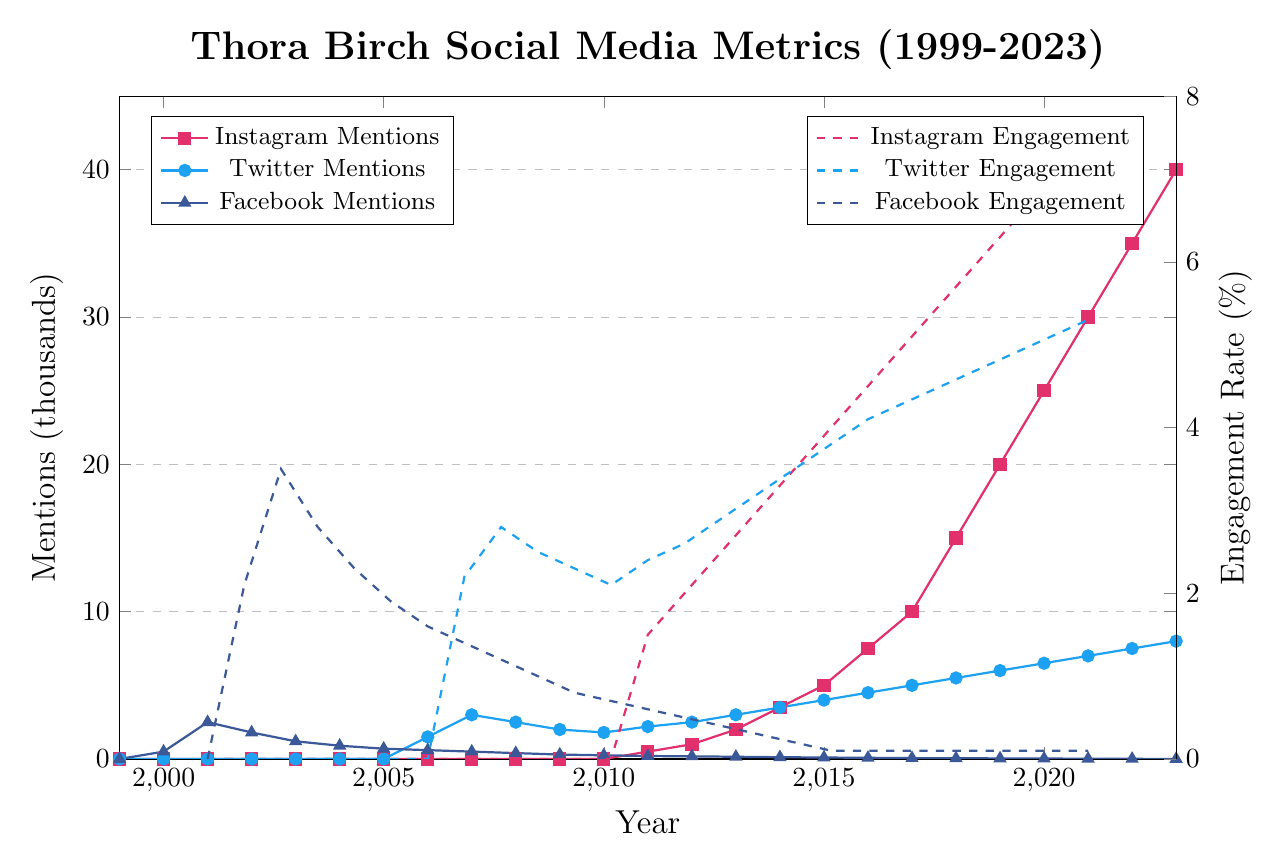What's the overall trend in Instagram mentions from 1999 to 2023? The figure shows a steady increase in Instagram mentions starting from 2011, reaching 40,000 in 2023. Initially, there were no mentions from 1999 to 2010.
Answer: Increasing How do the Twitter and Facebook mentions in 2007 compare? In 2007, Twitter mentions are represented by the blue line and marker, while Facebook mentions are represented by the blue line and triangle marker. Twitter mentions are at 3,000 and Facebook mentions are at 500. Thus, Twitter mentions are more than Facebook mentions.
Answer: Twitter mentions are more In which year did Instagram engagement first appear, and what was the rate? Instagram engagement first appears in 2011, as indicated by the red dashed line on the right y-axis, and the rate was 1.5%.
Answer: 2011, 1.5% What was the change in Facebook engagement from 2001 to 2023? In 2001, Facebook engagement was 3.5%, represented by the blue dashed line and triangle marker. By 2023, it dropped to 0.1%. The change in engagement is 3.5% - 0.1% = 3.4%.
Answer: Decreased by 3.4% What year had the highest Twitter engagement rate, and what was the value? The highest Twitter engagement rate is observed in 2023, as indicated by the peak of the blue dashed line, and the value is 5.3%.
Answer: 2023, 5.3% Which social media platform had the highest mentions in 2018? In 2018, the red line is the highest around 15,000 mentions, which represents Instagram. Twitter, represented by the blue line, has about 5,500 mentions. Facebook, represented by the blue line and triangle marker, has about 50 mentions. Instagram had the highest mentions.
Answer: Instagram Compare the Instagram and Twitter engagement rates in 2020. Which is higher and by how much? In 2020, the red dashed line (Instagram) shows an engagement rate of 6% and the blue dashed line (Twitter) shows an engagement rate of 4.7%. The difference is 6% - 4.7% = 1.3%. Instagram engagement is higher by 1.3%.
Answer: Instagram by 1.3% When did Twitter mentions surpass Facebook mentions, and what were the values? Twitter mentions surpassed Facebook mentions in 2006. In 2006, Twitter had 1,500 mentions (blue line) and Facebook had 600 mentions (blue line and triangle marker).
Answer: 2006, 1,500 (Twitter) and 600 (Facebook) What is the pattern observed in Facebook mentions from 1999 to 2023? Facebook mentions, seen through the blue line and triangle markers, had a peak early on in 2001 (around 2,500 mentions) and then gradually decreased to 5 mentions by 2023.
Answer: Decreasing trend 